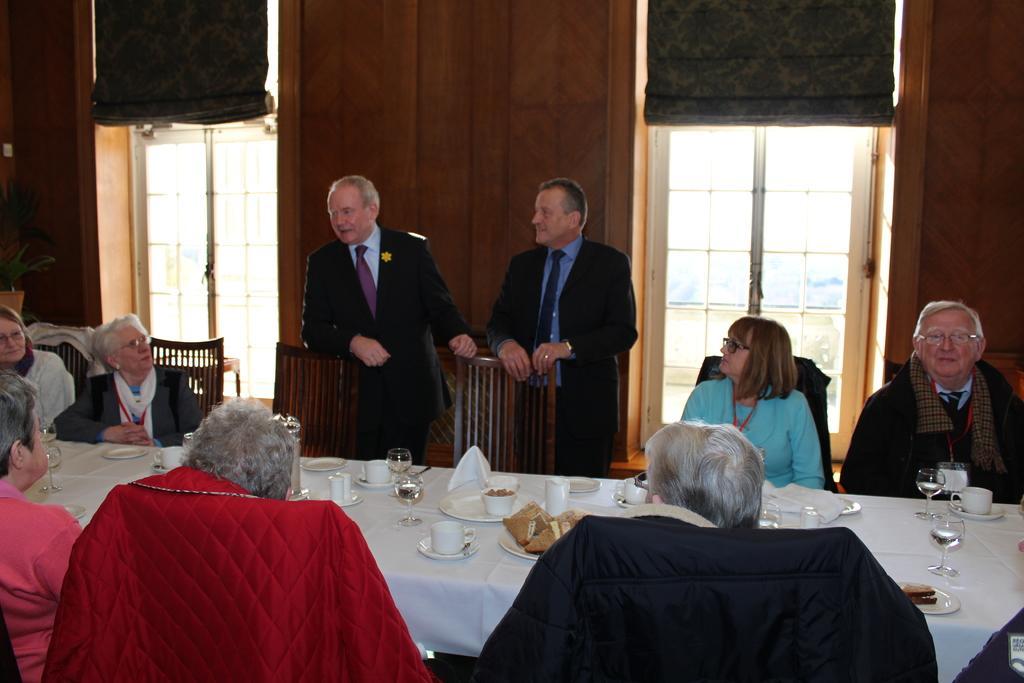Could you give a brief overview of what you see in this image? This picture describes about group of people few are seated on the chair and few are standing, in front of them we can find couple of glasses, plates, cups on the table in the background we can see window blinds and a plant. 